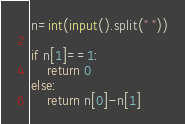Convert code to text. <code><loc_0><loc_0><loc_500><loc_500><_Python_>n=int(input().split(" "))

if n[1]==1:
    return 0
else:
    return n[0]-n[1]</code> 